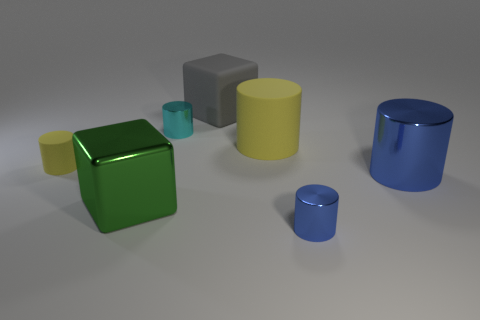Subtract all big matte cylinders. How many cylinders are left? 4 Add 1 small blue things. How many objects exist? 8 Add 7 green blocks. How many green blocks exist? 8 Subtract all yellow cylinders. How many cylinders are left? 3 Subtract 2 yellow cylinders. How many objects are left? 5 Subtract all cylinders. How many objects are left? 2 Subtract 3 cylinders. How many cylinders are left? 2 Subtract all cyan cubes. Subtract all green balls. How many cubes are left? 2 Subtract all cyan balls. How many gray cubes are left? 1 Subtract all large gray blocks. Subtract all yellow shiny blocks. How many objects are left? 6 